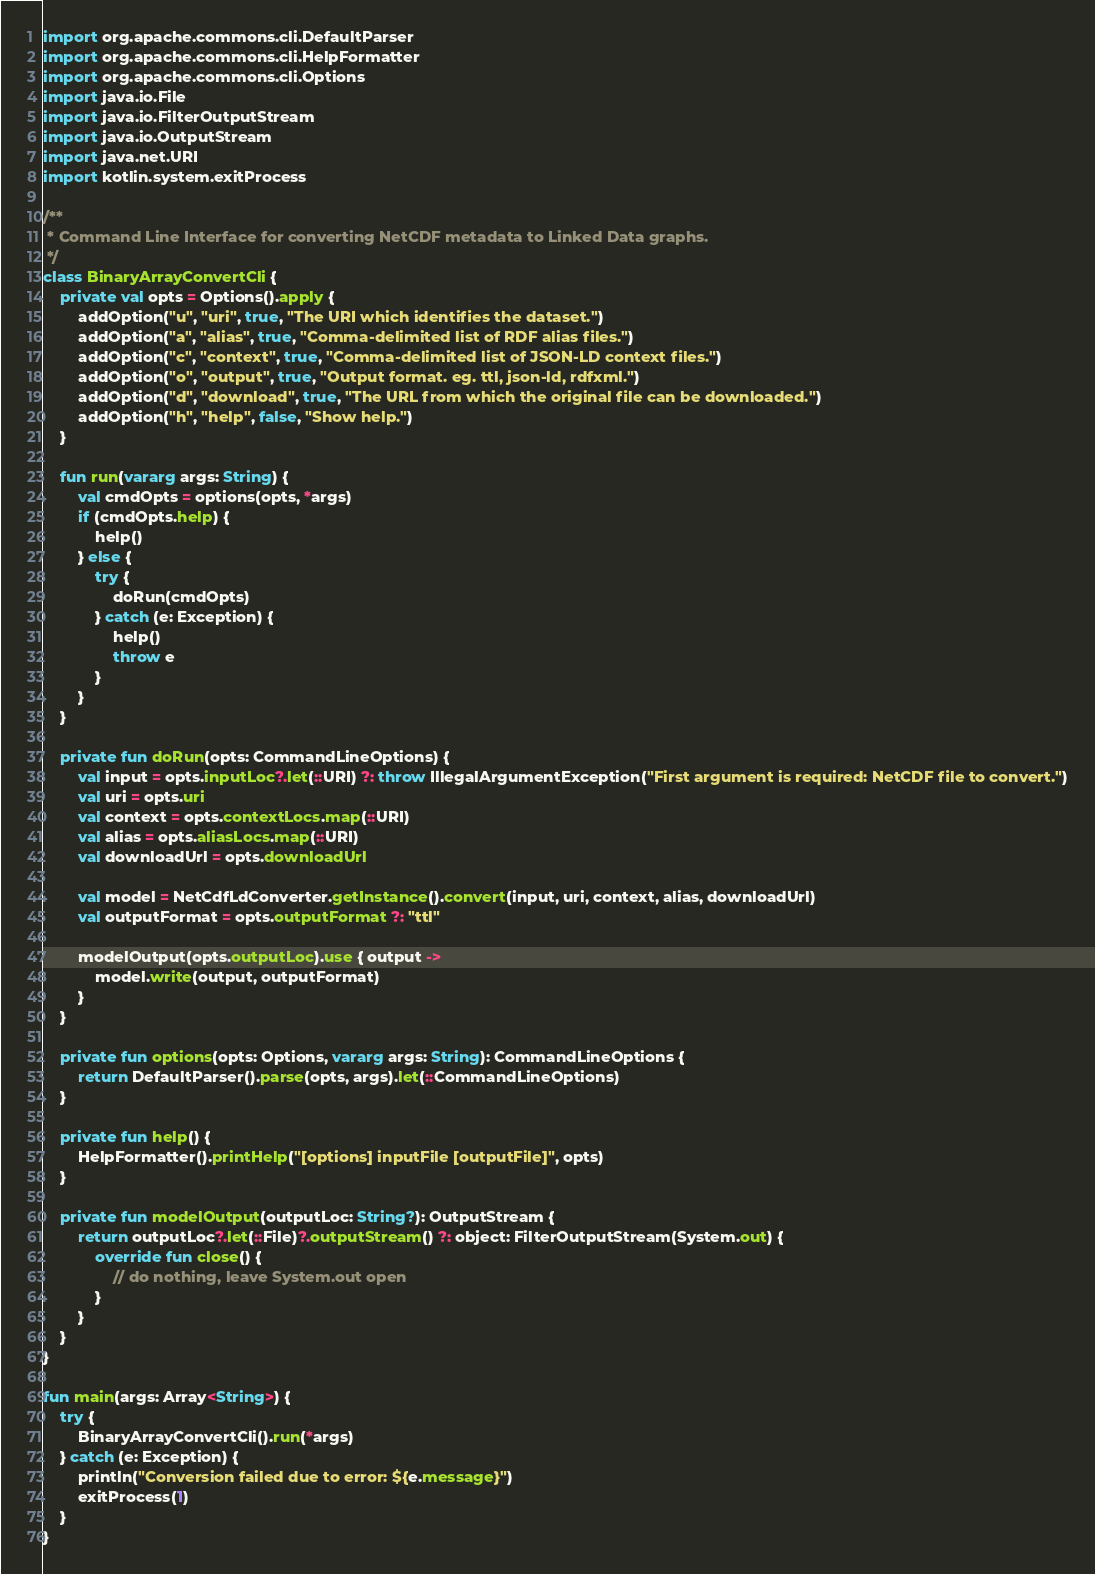Convert code to text. <code><loc_0><loc_0><loc_500><loc_500><_Kotlin_>import org.apache.commons.cli.DefaultParser
import org.apache.commons.cli.HelpFormatter
import org.apache.commons.cli.Options
import java.io.File
import java.io.FilterOutputStream
import java.io.OutputStream
import java.net.URI
import kotlin.system.exitProcess

/**
 * Command Line Interface for converting NetCDF metadata to Linked Data graphs.
 */
class BinaryArrayConvertCli {
    private val opts = Options().apply {
        addOption("u", "uri", true, "The URI which identifies the dataset.")
        addOption("a", "alias", true, "Comma-delimited list of RDF alias files.")
        addOption("c", "context", true, "Comma-delimited list of JSON-LD context files.")
        addOption("o", "output", true, "Output format. eg. ttl, json-ld, rdfxml.")
        addOption("d", "download", true, "The URL from which the original file can be downloaded.")
        addOption("h", "help", false, "Show help.")
    }

    fun run(vararg args: String) {
        val cmdOpts = options(opts, *args)
        if (cmdOpts.help) {
            help()
        } else {
            try {
                doRun(cmdOpts)
            } catch (e: Exception) {
                help()
                throw e
            }
        }
    }

    private fun doRun(opts: CommandLineOptions) {
        val input = opts.inputLoc?.let(::URI) ?: throw IllegalArgumentException("First argument is required: NetCDF file to convert.")
        val uri = opts.uri
        val context = opts.contextLocs.map(::URI)
        val alias = opts.aliasLocs.map(::URI)
        val downloadUrl = opts.downloadUrl

        val model = NetCdfLdConverter.getInstance().convert(input, uri, context, alias, downloadUrl)
        val outputFormat = opts.outputFormat ?: "ttl"

        modelOutput(opts.outputLoc).use { output ->
            model.write(output, outputFormat)
        }
    }

    private fun options(opts: Options, vararg args: String): CommandLineOptions {
        return DefaultParser().parse(opts, args).let(::CommandLineOptions)
    }

    private fun help() {
        HelpFormatter().printHelp("[options] inputFile [outputFile]", opts)
    }

    private fun modelOutput(outputLoc: String?): OutputStream {
        return outputLoc?.let(::File)?.outputStream() ?: object: FilterOutputStream(System.out) {
            override fun close() {
                // do nothing, leave System.out open
            }
        }
    }
}

fun main(args: Array<String>) {
    try {
        BinaryArrayConvertCli().run(*args)
    } catch (e: Exception) {
        println("Conversion failed due to error: ${e.message}")
        exitProcess(1)
    }
}
</code> 